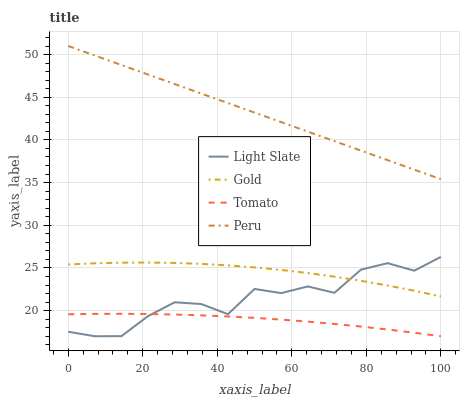Does Tomato have the minimum area under the curve?
Answer yes or no. Yes. Does Peru have the maximum area under the curve?
Answer yes or no. Yes. Does Peru have the minimum area under the curve?
Answer yes or no. No. Does Tomato have the maximum area under the curve?
Answer yes or no. No. Is Peru the smoothest?
Answer yes or no. Yes. Is Light Slate the roughest?
Answer yes or no. Yes. Is Tomato the smoothest?
Answer yes or no. No. Is Tomato the roughest?
Answer yes or no. No. Does Light Slate have the lowest value?
Answer yes or no. Yes. Does Peru have the lowest value?
Answer yes or no. No. Does Peru have the highest value?
Answer yes or no. Yes. Does Tomato have the highest value?
Answer yes or no. No. Is Light Slate less than Peru?
Answer yes or no. Yes. Is Peru greater than Light Slate?
Answer yes or no. Yes. Does Gold intersect Light Slate?
Answer yes or no. Yes. Is Gold less than Light Slate?
Answer yes or no. No. Is Gold greater than Light Slate?
Answer yes or no. No. Does Light Slate intersect Peru?
Answer yes or no. No. 